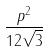<formula> <loc_0><loc_0><loc_500><loc_500>\frac { p ^ { 2 } } { 1 2 \sqrt { 3 } }</formula> 